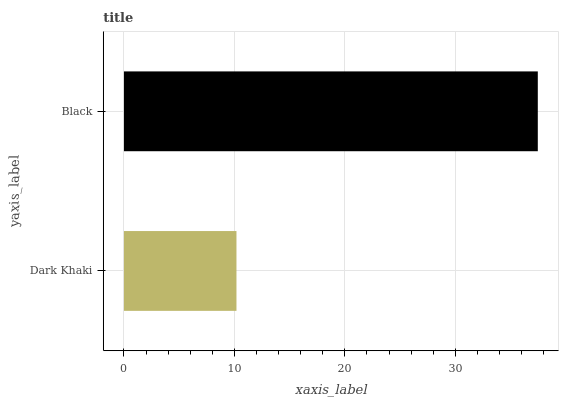Is Dark Khaki the minimum?
Answer yes or no. Yes. Is Black the maximum?
Answer yes or no. Yes. Is Black the minimum?
Answer yes or no. No. Is Black greater than Dark Khaki?
Answer yes or no. Yes. Is Dark Khaki less than Black?
Answer yes or no. Yes. Is Dark Khaki greater than Black?
Answer yes or no. No. Is Black less than Dark Khaki?
Answer yes or no. No. Is Black the high median?
Answer yes or no. Yes. Is Dark Khaki the low median?
Answer yes or no. Yes. Is Dark Khaki the high median?
Answer yes or no. No. Is Black the low median?
Answer yes or no. No. 